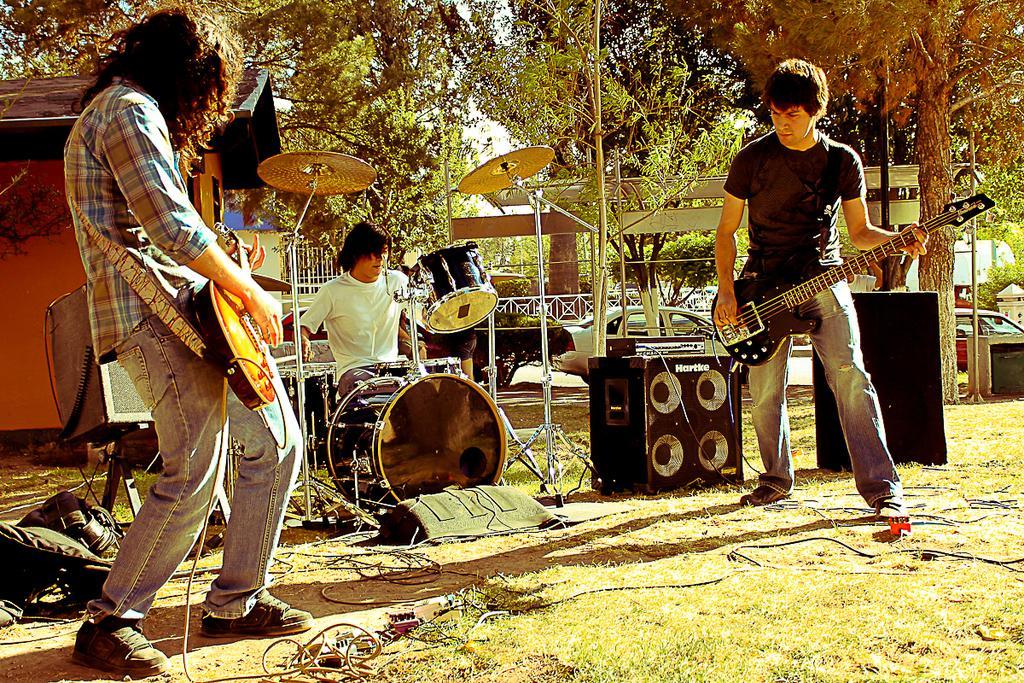In one or two sentences, can you explain what this image depicts? In this image I can see three people were two of them are holding guitar in their hands. I can see a person is sitting next to a drum set. In the background I can see number of trees and a shack. 